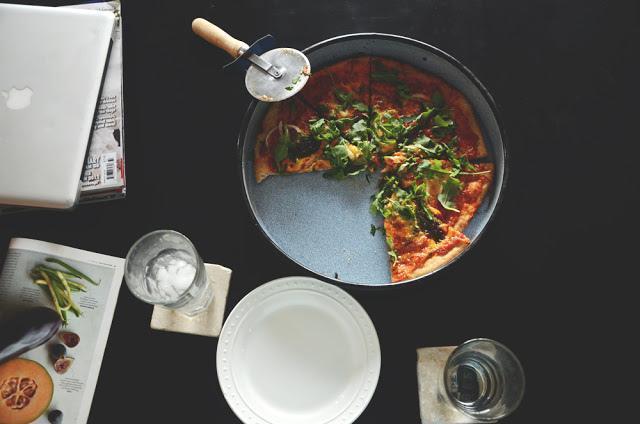How many books are in the picture?
Give a very brief answer. 2. How many cups are there?
Give a very brief answer. 2. 